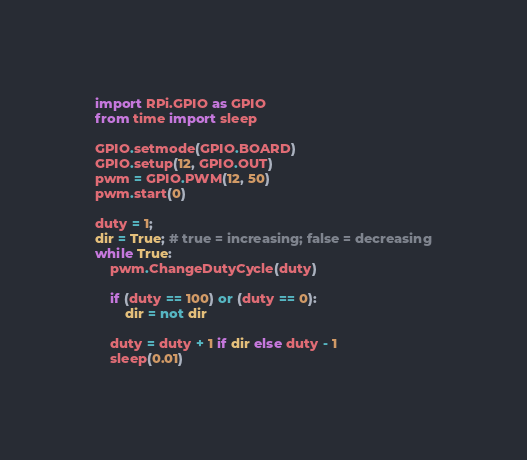Convert code to text. <code><loc_0><loc_0><loc_500><loc_500><_Python_>import RPi.GPIO as GPIO
from time import sleep

GPIO.setmode(GPIO.BOARD)
GPIO.setup(12, GPIO.OUT)
pwm = GPIO.PWM(12, 50)
pwm.start(0)

duty = 1;
dir = True; # true = increasing; false = decreasing
while True: 
    pwm.ChangeDutyCycle(duty)
    
    if (duty == 100) or (duty == 0):
        dir = not dir 
    
    duty = duty + 1 if dir else duty - 1
    sleep(0.01)

</code> 